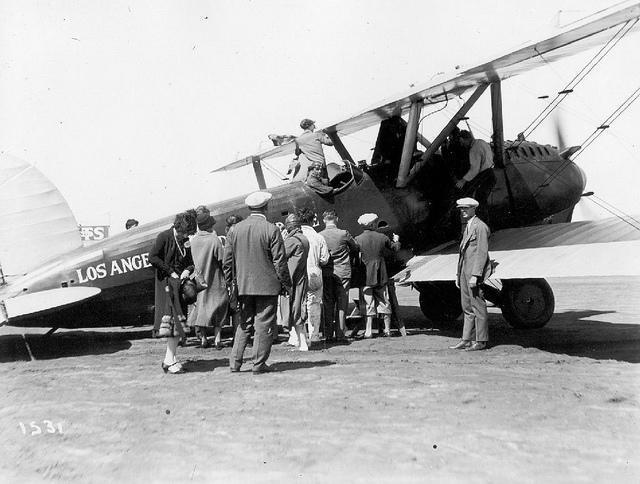How many people are in the photo?
Give a very brief answer. 8. 